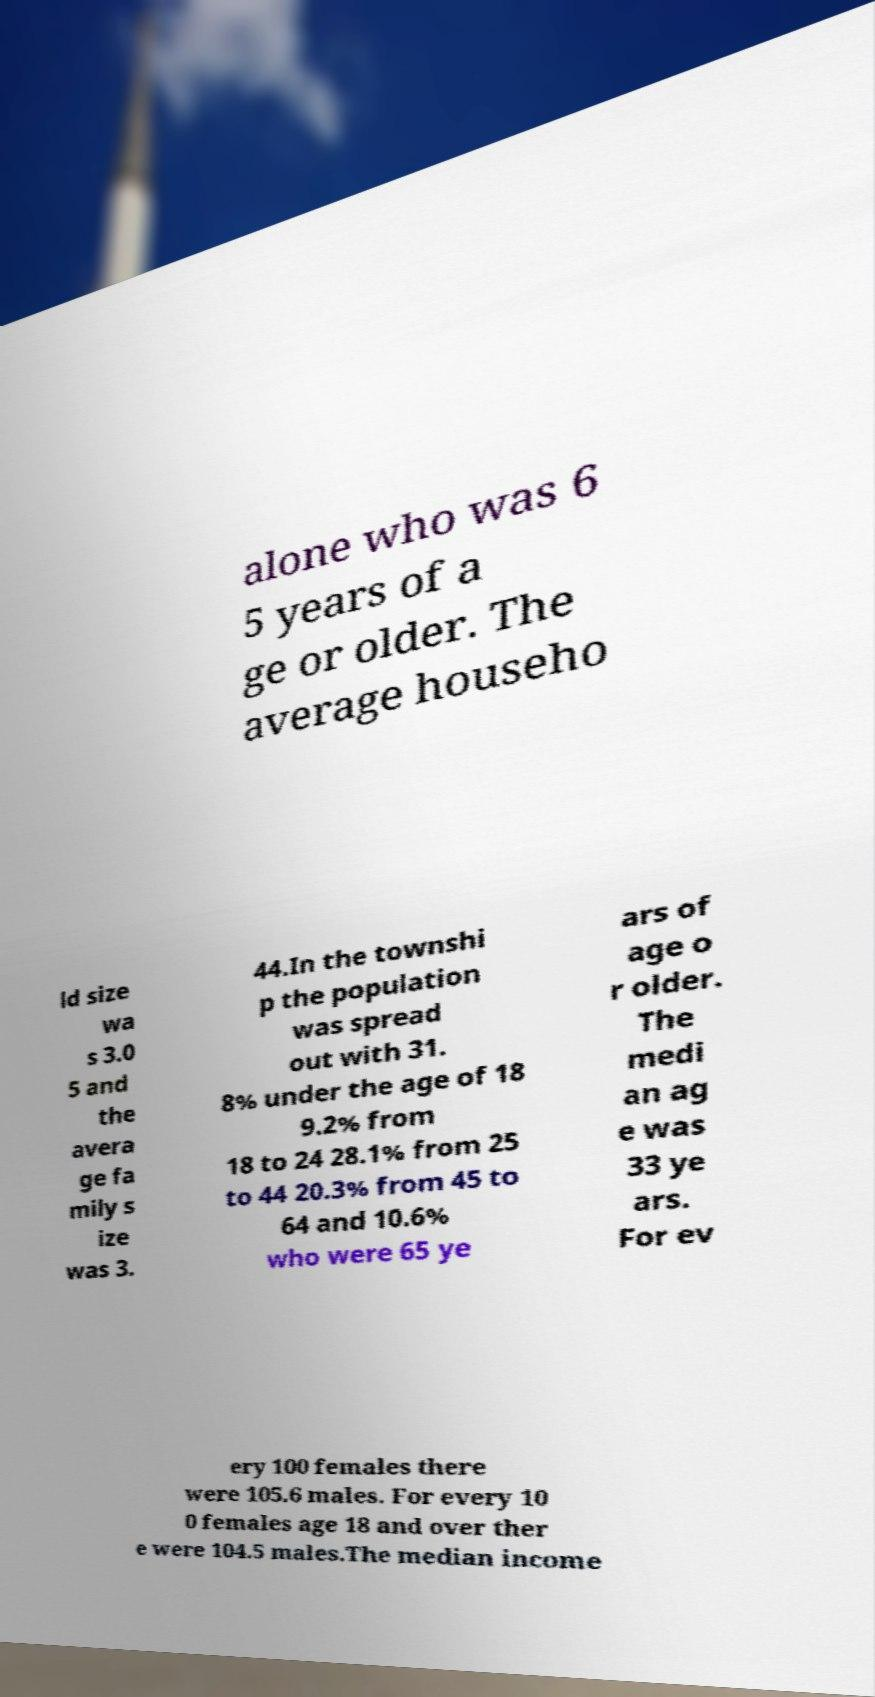Could you extract and type out the text from this image? alone who was 6 5 years of a ge or older. The average househo ld size wa s 3.0 5 and the avera ge fa mily s ize was 3. 44.In the townshi p the population was spread out with 31. 8% under the age of 18 9.2% from 18 to 24 28.1% from 25 to 44 20.3% from 45 to 64 and 10.6% who were 65 ye ars of age o r older. The medi an ag e was 33 ye ars. For ev ery 100 females there were 105.6 males. For every 10 0 females age 18 and over ther e were 104.5 males.The median income 